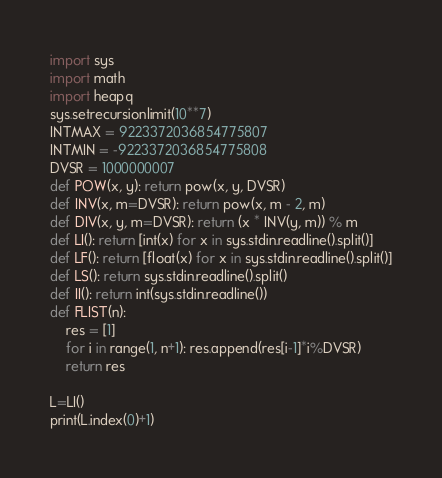<code> <loc_0><loc_0><loc_500><loc_500><_Python_>import sys
import math
import heapq
sys.setrecursionlimit(10**7)
INTMAX = 9223372036854775807
INTMIN = -9223372036854775808
DVSR = 1000000007
def POW(x, y): return pow(x, y, DVSR)
def INV(x, m=DVSR): return pow(x, m - 2, m)
def DIV(x, y, m=DVSR): return (x * INV(y, m)) % m
def LI(): return [int(x) for x in sys.stdin.readline().split()]
def LF(): return [float(x) for x in sys.stdin.readline().split()]
def LS(): return sys.stdin.readline().split()
def II(): return int(sys.stdin.readline())
def FLIST(n):
    res = [1]
    for i in range(1, n+1): res.append(res[i-1]*i%DVSR)
    return res

L=LI()
print(L.index(0)+1)
</code> 